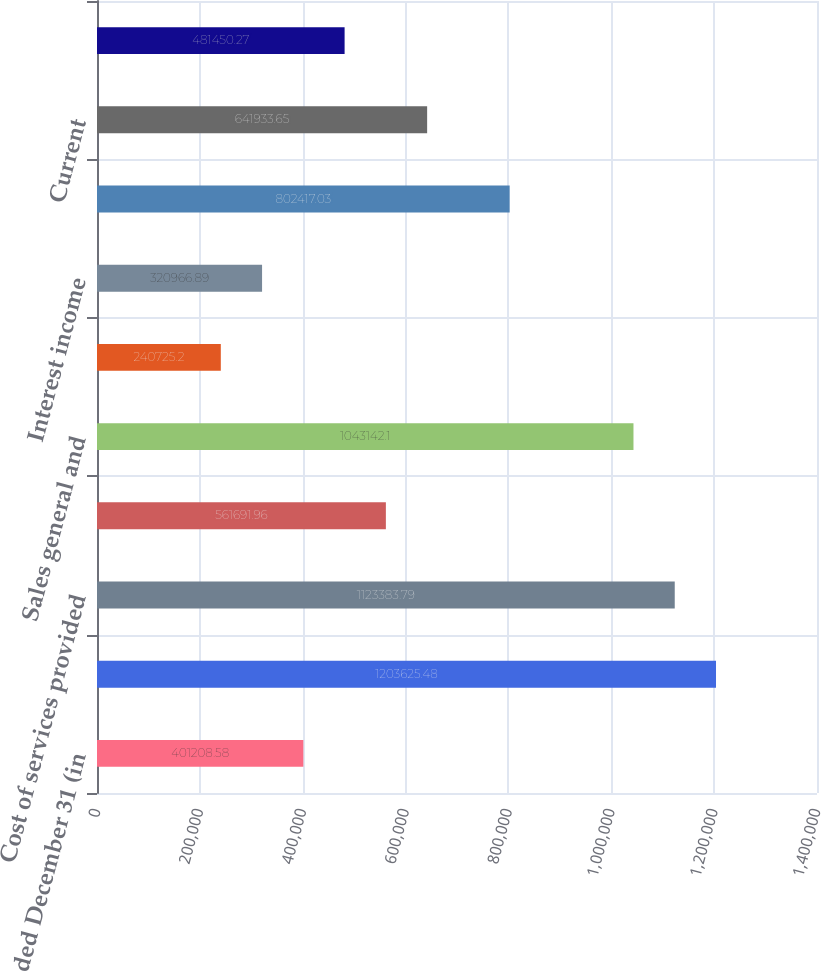Convert chart. <chart><loc_0><loc_0><loc_500><loc_500><bar_chart><fcel>Years ended December 31 (in<fcel>Customer services<fcel>Cost of services provided<fcel>Depreciation and amortization<fcel>Sales general and<fcel>Gain on sales of assets<fcel>Interest income<fcel>INCOME BEFORE INCOME TAXES<fcel>Current<fcel>Deferred<nl><fcel>401209<fcel>1.20363e+06<fcel>1.12338e+06<fcel>561692<fcel>1.04314e+06<fcel>240725<fcel>320967<fcel>802417<fcel>641934<fcel>481450<nl></chart> 